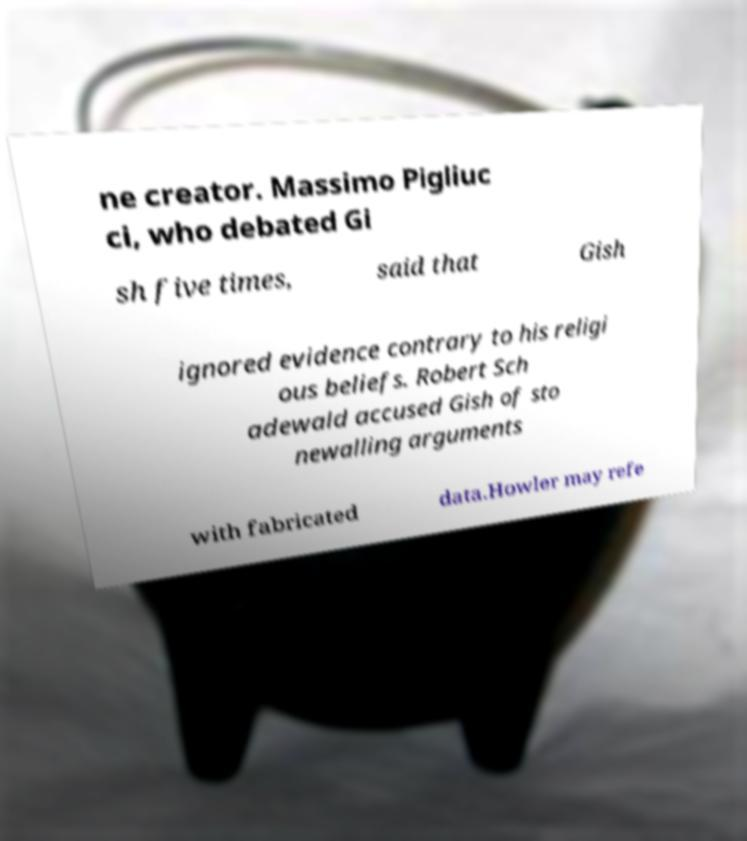Please read and relay the text visible in this image. What does it say? ne creator. Massimo Pigliuc ci, who debated Gi sh five times, said that Gish ignored evidence contrary to his religi ous beliefs. Robert Sch adewald accused Gish of sto newalling arguments with fabricated data.Howler may refe 